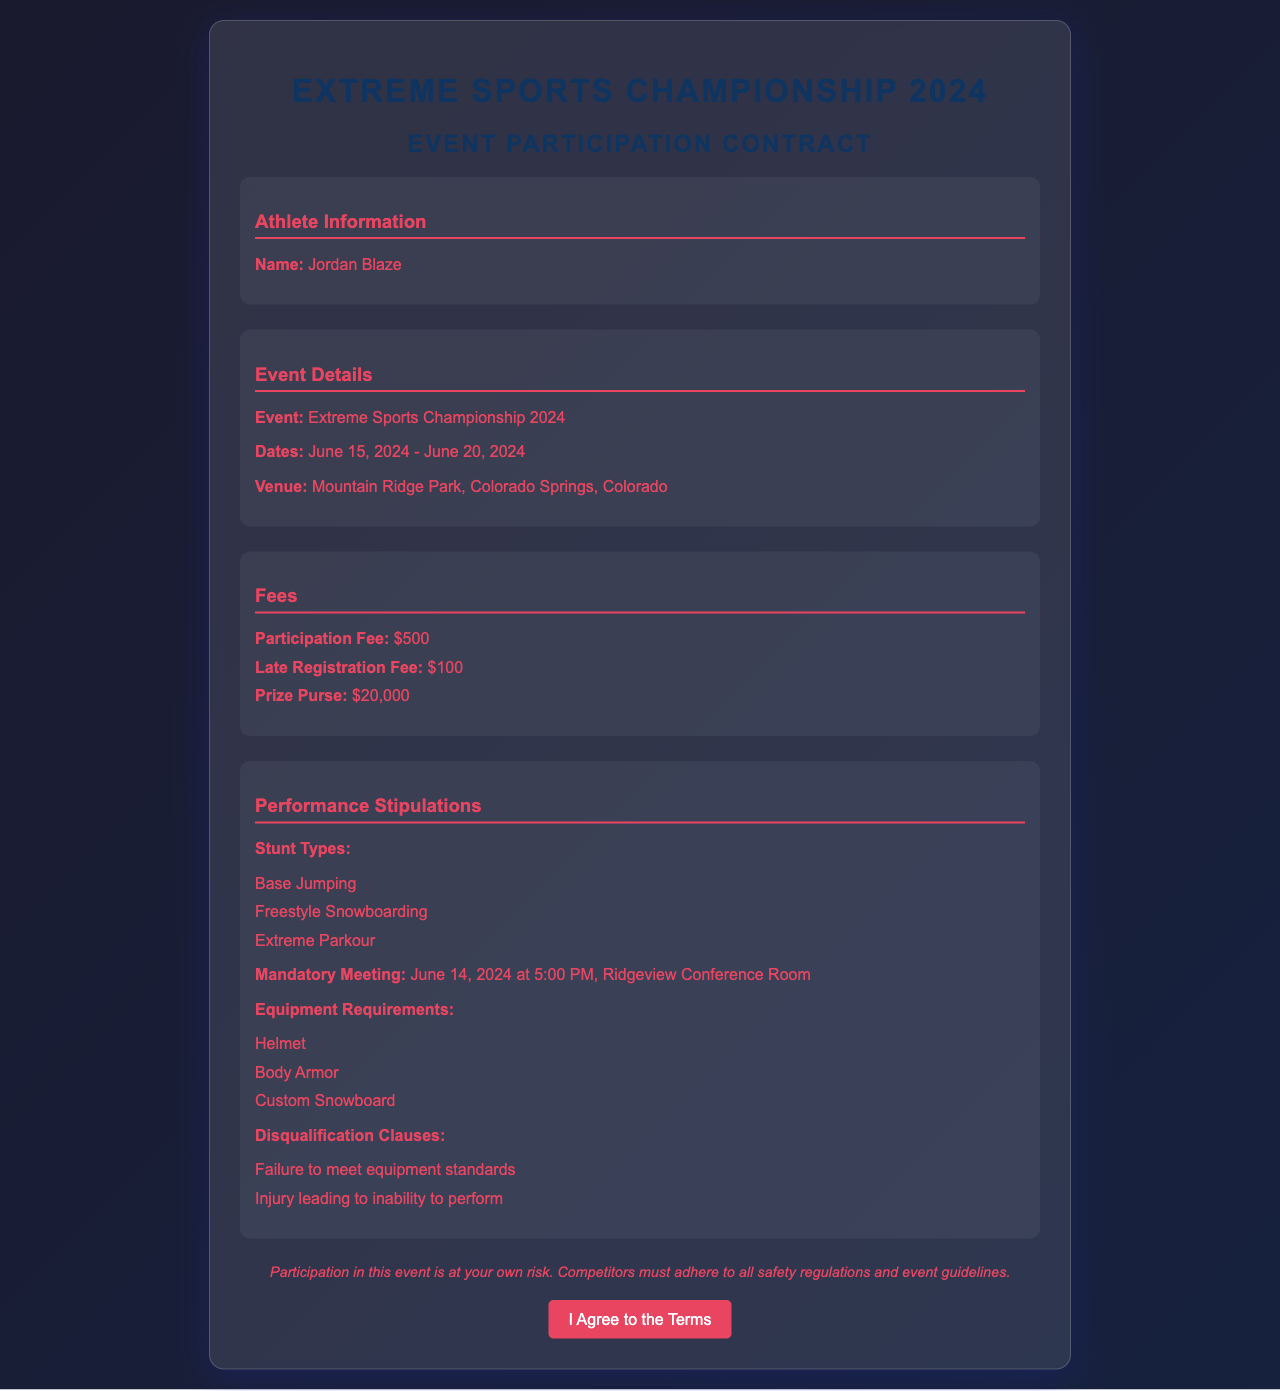What is the name of the athlete? The athlete's name is explicitly provided in the document under the Athlete Information section.
Answer: Jordan Blaze What are the event dates? The event dates are listed clearly in the Document under the Event Details section.
Answer: June 15, 2024 - June 20, 2024 What is the venue for the championship? The venue information is specifically mentioned in the Event Details section of the document.
Answer: Mountain Ridge Park, Colorado Springs, Colorado What is the participation fee? The fee is explicitly stated in the Fees section.
Answer: $500 What is the prize purse amount? The prize purse information is found in the Fees section of the document.
Answer: $20,000 What is the mandatory meeting date and time? The date and time are listed in the Performance Stipulations section, highlighting important event schedules.
Answer: June 14, 2024 at 5:00 PM What equipment is required? The equipment requirements are outlined clearly in the Performance Stipulations section.
Answer: Helmet, Body Armor, Custom Snowboard What are the disqualification clauses? The disqualification clauses are specified in the Performance Stipulations section, emphasizing important rule compliance.
Answer: Failure to meet equipment standards, Injury leading to inability to perform What types of stunts are allowed? The permitted stunt types are explicitly listed in the Performance Stipulations section.
Answer: Base Jumping, Freestyle Snowboarding, Extreme Parkour 